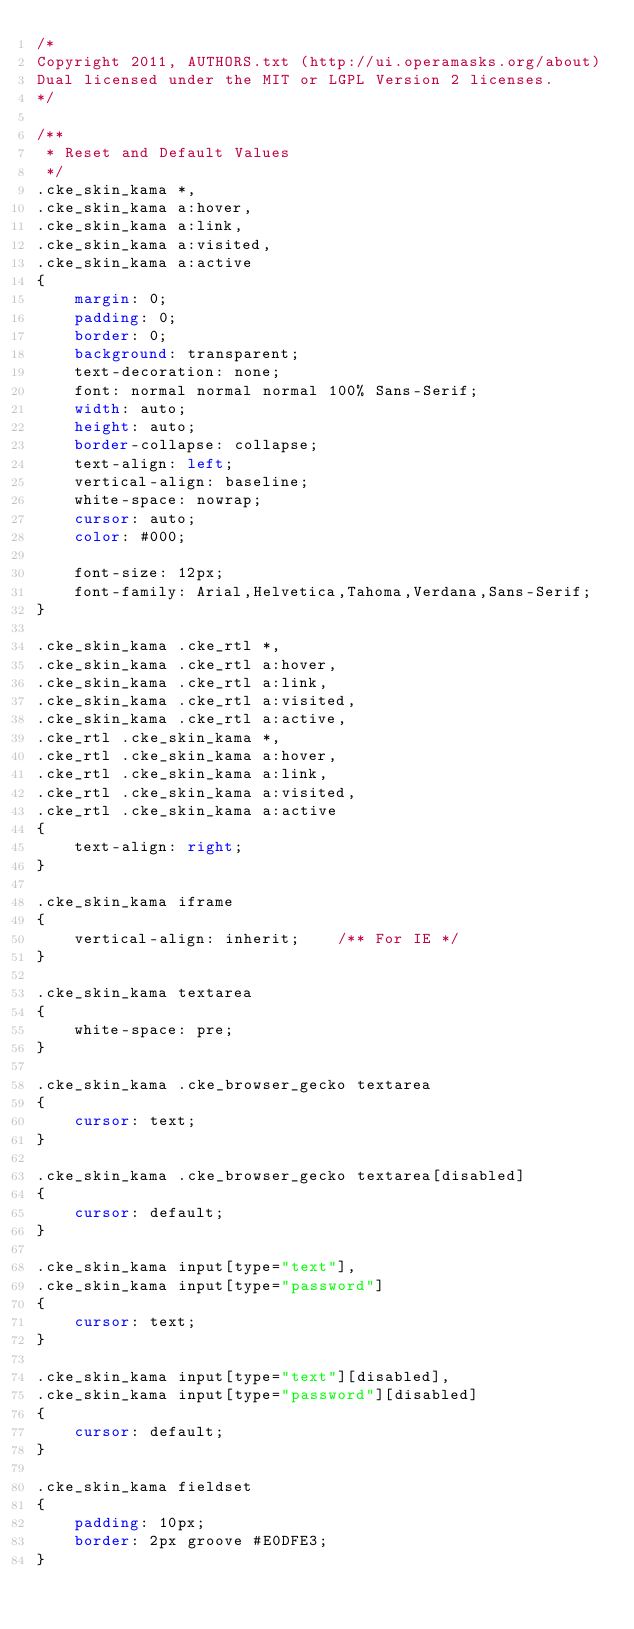<code> <loc_0><loc_0><loc_500><loc_500><_CSS_>/*
Copyright 2011, AUTHORS.txt (http://ui.operamasks.org/about)
Dual licensed under the MIT or LGPL Version 2 licenses.
*/

/**
 * Reset and Default Values
 */
.cke_skin_kama *,
.cke_skin_kama a:hover,
.cke_skin_kama a:link,
.cke_skin_kama a:visited,
.cke_skin_kama a:active
{
	margin: 0;
	padding: 0;
	border: 0;
	background: transparent;
	text-decoration: none;
	font: normal normal normal 100% Sans-Serif;
	width: auto;
	height: auto;
	border-collapse: collapse;
	text-align: left;
	vertical-align: baseline;
	white-space: nowrap;
	cursor: auto;
	color: #000;

    font-size: 12px;
    font-family: Arial,Helvetica,Tahoma,Verdana,Sans-Serif;
}

.cke_skin_kama .cke_rtl *,
.cke_skin_kama .cke_rtl a:hover,
.cke_skin_kama .cke_rtl a:link,
.cke_skin_kama .cke_rtl a:visited,
.cke_skin_kama .cke_rtl a:active,
.cke_rtl .cke_skin_kama *,
.cke_rtl .cke_skin_kama a:hover,
.cke_rtl .cke_skin_kama a:link,
.cke_rtl .cke_skin_kama a:visited,
.cke_rtl .cke_skin_kama a:active
{
	text-align: right;
}

.cke_skin_kama iframe
{
	vertical-align: inherit;	/** For IE */
}

.cke_skin_kama textarea
{
	white-space: pre;
}

.cke_skin_kama .cke_browser_gecko textarea
{
	cursor: text;
}

.cke_skin_kama .cke_browser_gecko textarea[disabled]
{
	cursor: default;
}

.cke_skin_kama input[type="text"],
.cke_skin_kama input[type="password"]
{
	cursor: text;
}

.cke_skin_kama input[type="text"][disabled],
.cke_skin_kama input[type="password"][disabled]
{
	cursor: default;
}

.cke_skin_kama fieldset
{
	padding: 10px;
	border: 2px groove #E0DFE3;
}
</code> 